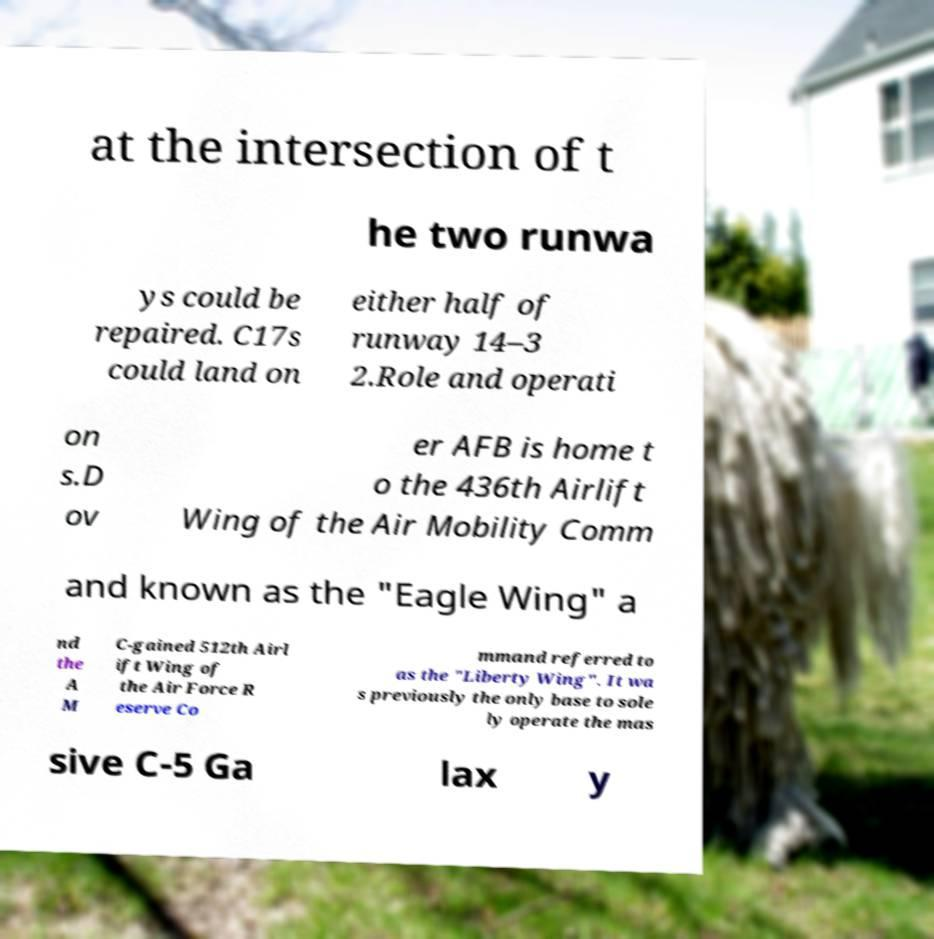Could you extract and type out the text from this image? at the intersection of t he two runwa ys could be repaired. C17s could land on either half of runway 14–3 2.Role and operati on s.D ov er AFB is home t o the 436th Airlift Wing of the Air Mobility Comm and known as the "Eagle Wing" a nd the A M C-gained 512th Airl ift Wing of the Air Force R eserve Co mmand referred to as the "Liberty Wing". It wa s previously the only base to sole ly operate the mas sive C-5 Ga lax y 